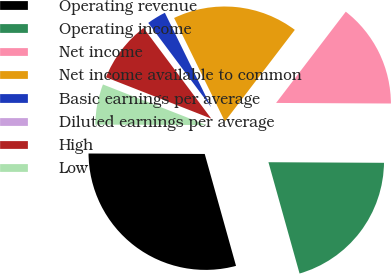<chart> <loc_0><loc_0><loc_500><loc_500><pie_chart><fcel>Operating revenue<fcel>Operating income<fcel>Net income<fcel>Net income available to common<fcel>Basic earnings per average<fcel>Diluted earnings per average<fcel>High<fcel>Low<nl><fcel>29.4%<fcel>20.58%<fcel>14.7%<fcel>17.64%<fcel>2.95%<fcel>0.01%<fcel>8.83%<fcel>5.89%<nl></chart> 